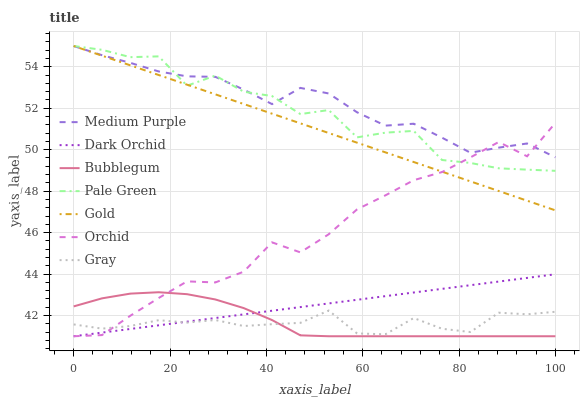Does Gray have the minimum area under the curve?
Answer yes or no. Yes. Does Medium Purple have the maximum area under the curve?
Answer yes or no. Yes. Does Gold have the minimum area under the curve?
Answer yes or no. No. Does Gold have the maximum area under the curve?
Answer yes or no. No. Is Gold the smoothest?
Answer yes or no. Yes. Is Pale Green the roughest?
Answer yes or no. Yes. Is Bubblegum the smoothest?
Answer yes or no. No. Is Bubblegum the roughest?
Answer yes or no. No. Does Bubblegum have the lowest value?
Answer yes or no. Yes. Does Gold have the lowest value?
Answer yes or no. No. Does Pale Green have the highest value?
Answer yes or no. Yes. Does Bubblegum have the highest value?
Answer yes or no. No. Is Dark Orchid less than Pale Green?
Answer yes or no. Yes. Is Medium Purple greater than Gray?
Answer yes or no. Yes. Does Gray intersect Orchid?
Answer yes or no. Yes. Is Gray less than Orchid?
Answer yes or no. No. Is Gray greater than Orchid?
Answer yes or no. No. Does Dark Orchid intersect Pale Green?
Answer yes or no. No. 